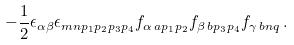Convert formula to latex. <formula><loc_0><loc_0><loc_500><loc_500>- \frac { 1 } { 2 } \epsilon _ { \alpha \beta } \epsilon _ { m n p _ { 1 } p _ { 2 } p _ { 3 } p _ { 4 } } f _ { \alpha \, a p _ { 1 } p _ { 2 } } f _ { \beta \, b p _ { 3 } p _ { 4 } } f _ { \gamma \, b n q } \, .</formula> 